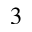<formula> <loc_0><loc_0><loc_500><loc_500>_ { 3 }</formula> 